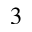<formula> <loc_0><loc_0><loc_500><loc_500>_ { 3 }</formula> 